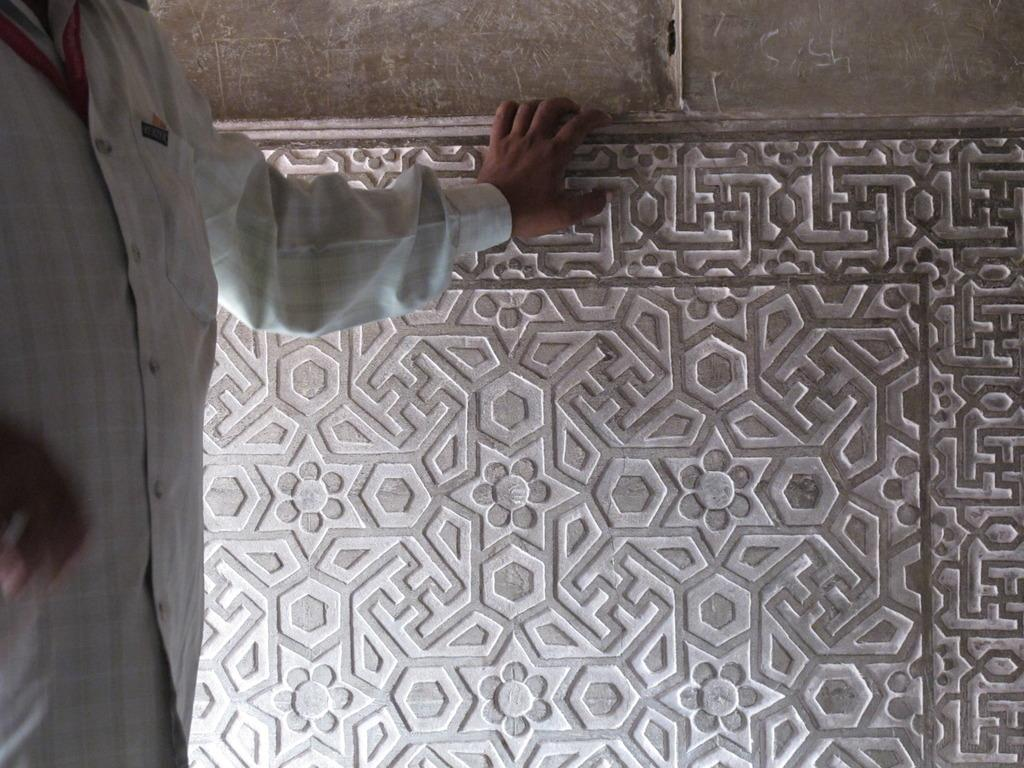What is the main feature of the image? There is a big wall with a design in the image. What is the person in the image doing? The person is standing and holding the wall. How can we identify the person in the image? The person has a red tag. What type of twig can be seen in the person's throat in the image? There is no twig or any indication of a throat issue in the image. How does the clam contribute to the design of the wall in the image? There are no clams present in the image; the wall has a design but no mention of clams. 